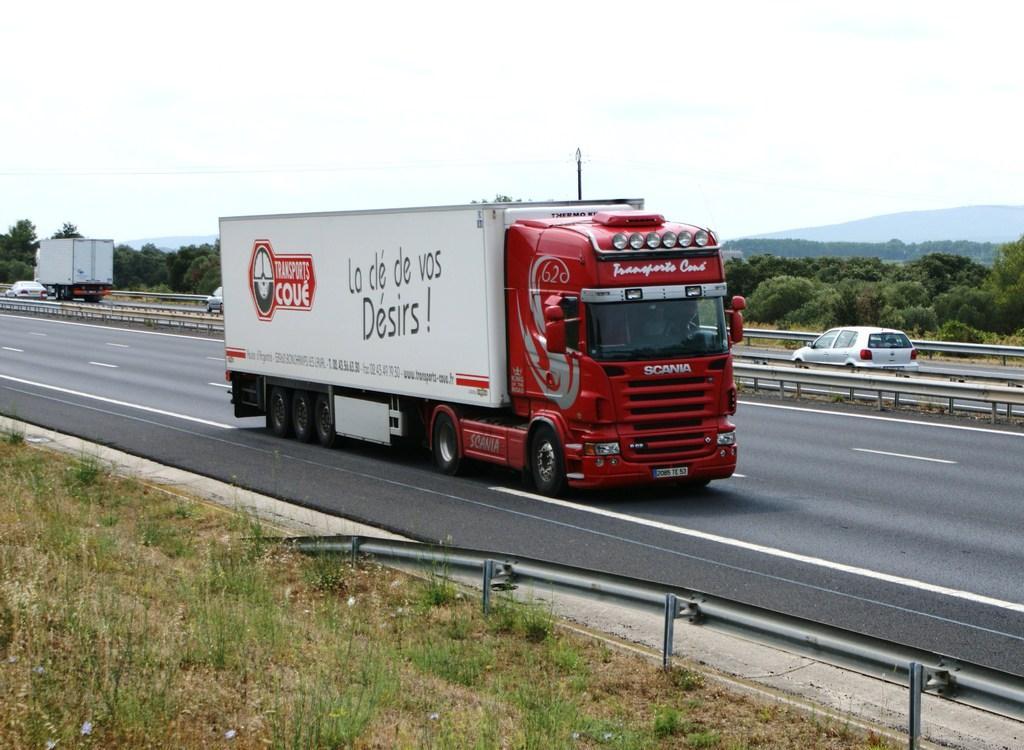How would you summarize this image in a sentence or two? This image is taken outdoors. At the bottom of the image there is a ground with grass on it and there is a road. In the middle of the image a truck is moving on the road. In the background a few vehicles are moving on the road and there is a railing. There are many trees and a hill. At the top of the image there is a sky. 